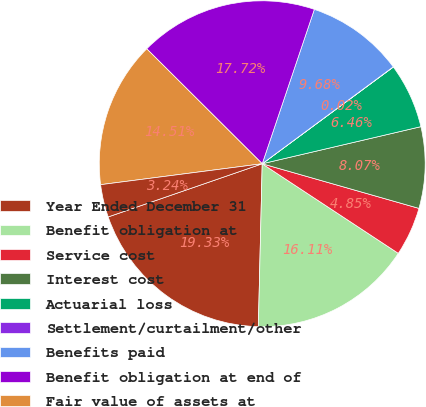<chart> <loc_0><loc_0><loc_500><loc_500><pie_chart><fcel>Year Ended December 31<fcel>Benefit obligation at<fcel>Service cost<fcel>Interest cost<fcel>Actuarial loss<fcel>Settlement/curtailment/other<fcel>Benefits paid<fcel>Benefit obligation at end of<fcel>Fair value of assets at<fcel>Actual return on plan assets<nl><fcel>19.33%<fcel>16.11%<fcel>4.85%<fcel>8.07%<fcel>6.46%<fcel>0.02%<fcel>9.68%<fcel>17.72%<fcel>14.51%<fcel>3.24%<nl></chart> 